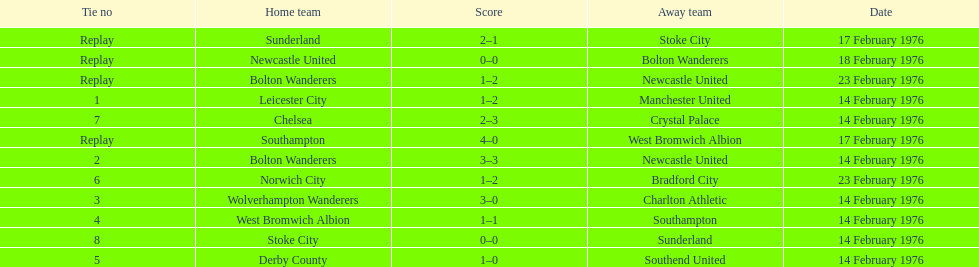How many games were replays? 4. 